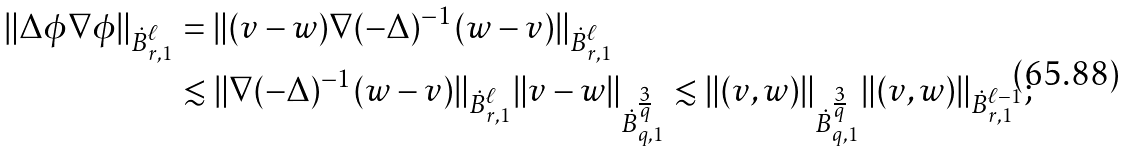Convert formula to latex. <formula><loc_0><loc_0><loc_500><loc_500>\| \Delta \phi \nabla \phi \| _ { \dot { B } ^ { \ell } _ { r , 1 } } & = \| ( v - w ) \nabla ( - \Delta ) ^ { - 1 } ( w - v ) \| _ { \dot { B } ^ { \ell } _ { r , 1 } } \\ & \lesssim \| \nabla ( - \Delta ) ^ { - 1 } ( w - v ) \| _ { \dot { B } ^ { \ell } _ { r , 1 } } \| v - w \| _ { \dot { B } ^ { \frac { 3 } { q } } _ { q , 1 } } \lesssim \| ( v , w ) \| _ { \dot { B } ^ { \frac { 3 } { q } } _ { q , 1 } } \| ( v , w ) \| _ { \dot { B } ^ { \ell - 1 } _ { r , 1 } } ;</formula> 